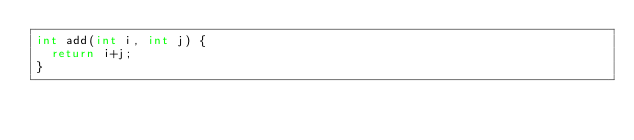<code> <loc_0><loc_0><loc_500><loc_500><_C_>int add(int i, int j) {
  return i+j;
}</code> 